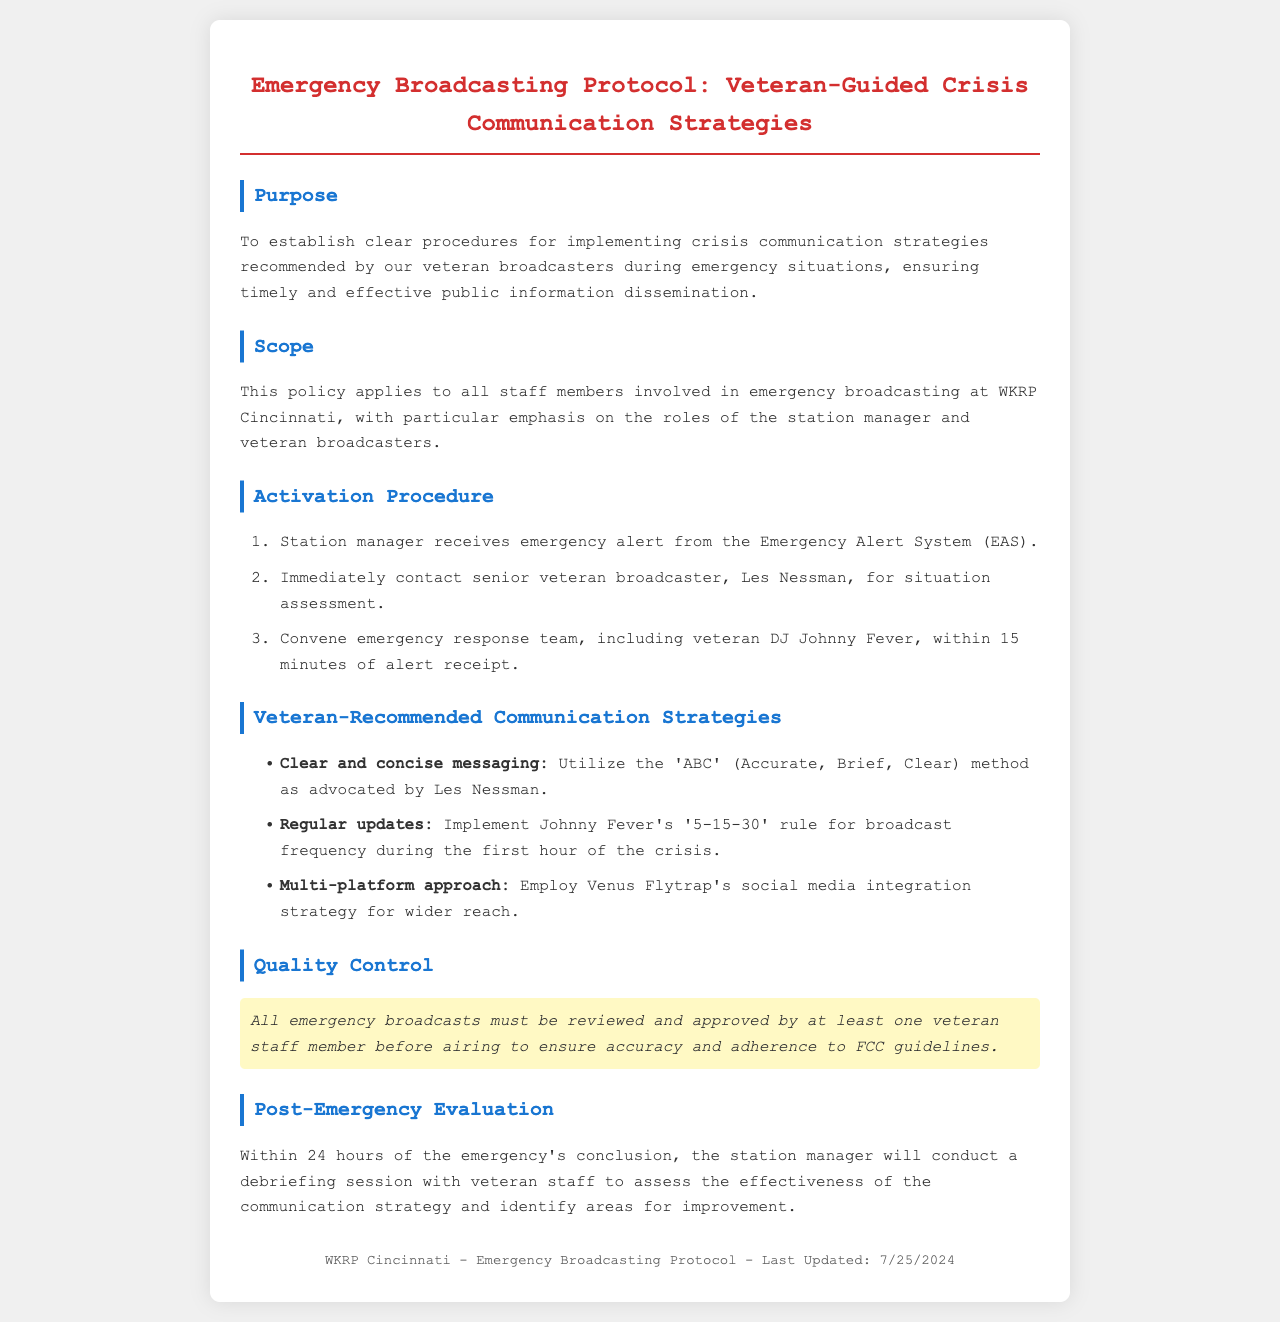What is the purpose of the protocol? The purpose outlines the goal of the document, which is to establish clear procedures for crisis communication strategies recommended by veterans.
Answer: To establish clear procedures for implementing crisis communication strategies Who is the senior veteran broadcaster to contact? This information identifies the designated senior veteran broadcaster to contact during an emergency situation.
Answer: Les Nessman What is the maximum time to convene the emergency response team? This question seeks specific time information for a critical step in the activation procedure.
Answer: 15 minutes What is the '5-15-30' rule? This refers to specific guidelines recommended by a veteran regarding broadcast frequency during a crisis.
Answer: Johnny Fever's broadcast frequency rule What must be done before airing emergency broadcasts? This question focuses on who must review and approve the broadcasts for compliance and accuracy.
Answer: Reviewed and approved by at least one veteran staff member When should the post-emergency debriefing occur? The question pertains to the timeframe for conducting a debriefing session after an emergency, as stated in the protocol.
Answer: Within 24 hours Which communication strategy involves social media? This seeks to identify which veteran's strategy integrates social media for wider audience outreach.
Answer: Venus Flytrap's social media integration strategy What does 'ABC' stand for in communication strategies? This question asks for the specific components of the messaging method suggested by a veteran.
Answer: Accurate, Brief, Clear 